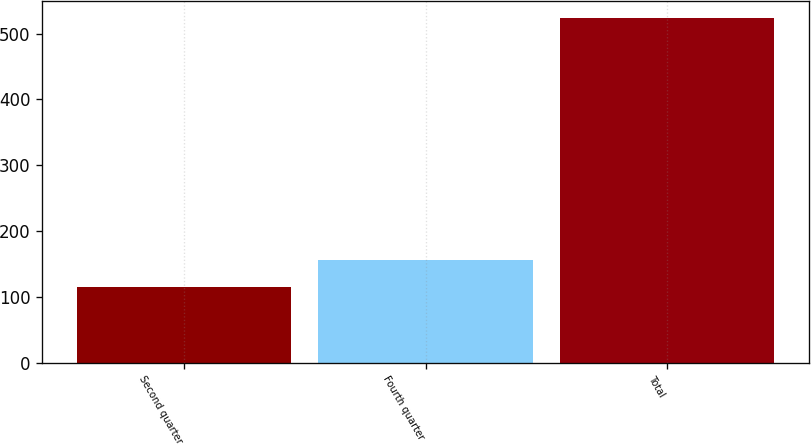<chart> <loc_0><loc_0><loc_500><loc_500><bar_chart><fcel>Second quarter<fcel>Fourth quarter<fcel>Total<nl><fcel>115<fcel>155.9<fcel>524<nl></chart> 